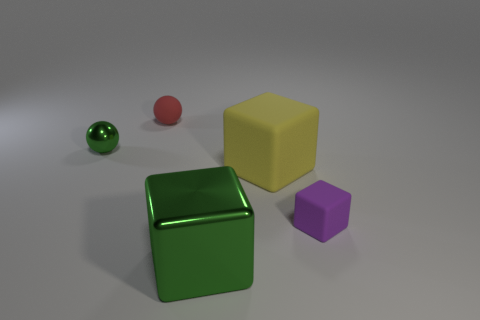Is the shape of the purple rubber thing the same as the green shiny thing that is behind the small purple cube? The shapes are not the same. The purple object in the foreground appears to be a small cube, while the green object, despite its similar cube-like appearance, has reflective surfaces that indicate it might be a different shape or material with a glossy finish. Moreover, the angles suggest that the green object could be slightly more rectangular than the purple one. 